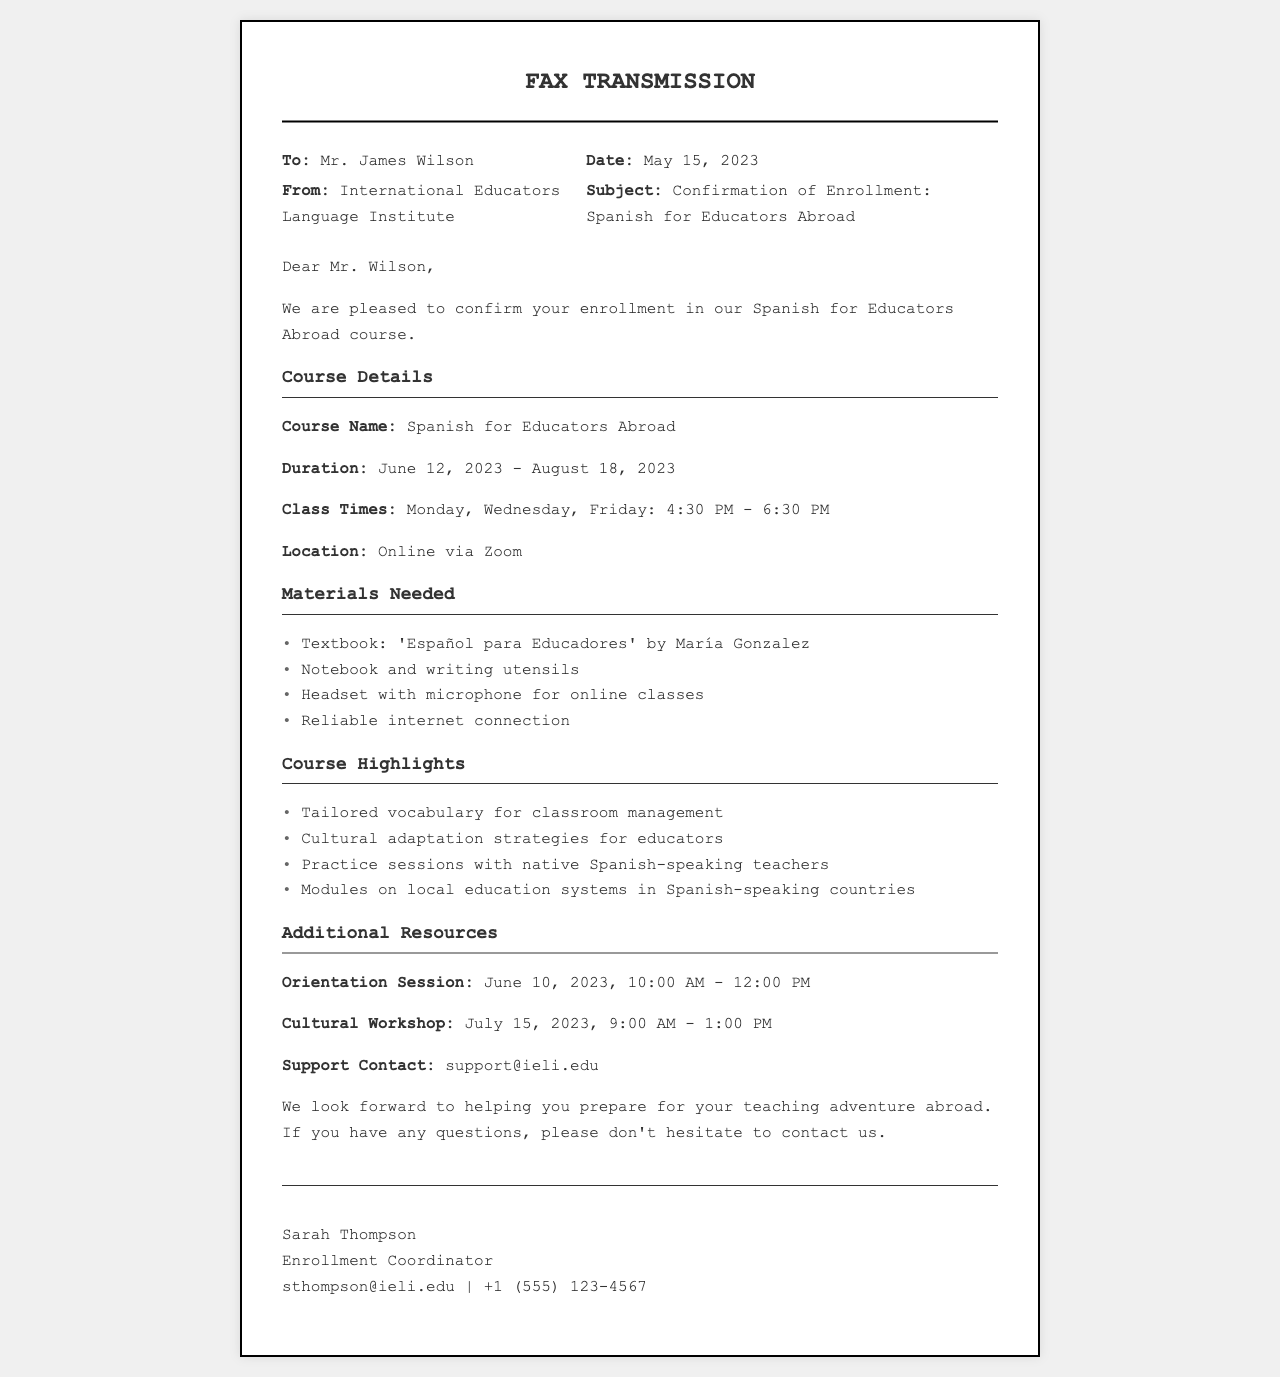What is the course name? The course name is explicitly stated in the document as "Spanish for Educators Abroad."
Answer: Spanish for Educators Abroad What is the duration of the course? The document specifies the duration of the course from June 12, 2023 to August 18, 2023.
Answer: June 12, 2023 - August 18, 2023 What days of the week are classes held? The document lists the class days as Monday, Wednesday, and Friday.
Answer: Monday, Wednesday, Friday What time do the classes start? The class times are provided in the document, indicating that they start at 4:30 PM.
Answer: 4:30 PM What type of internet connection is needed? The document states the requirement for a "reliable internet connection" for online classes.
Answer: Reliable internet connection What is one of the materials needed for the course? The document lists several materials needed, one of which is the textbook titled 'Español para Educadores' by María Gonzalez.
Answer: 'Español para Educadores' by María Gonzalez When is the orientation session? The document specifies the orientation session date as June 10, 2023, from 10:00 AM to 12:00 PM.
Answer: June 10, 2023, 10:00 AM - 12:00 PM Who is the support contact? The document provides a support contact email, specifically "support@ieli.edu."
Answer: support@ieli.edu What is the focus of the course highlights? The course highlights include "Cultural adaptation strategies for educators," showing the emphasis on acclimating to a new culture.
Answer: Cultural adaptation strategies for educators 